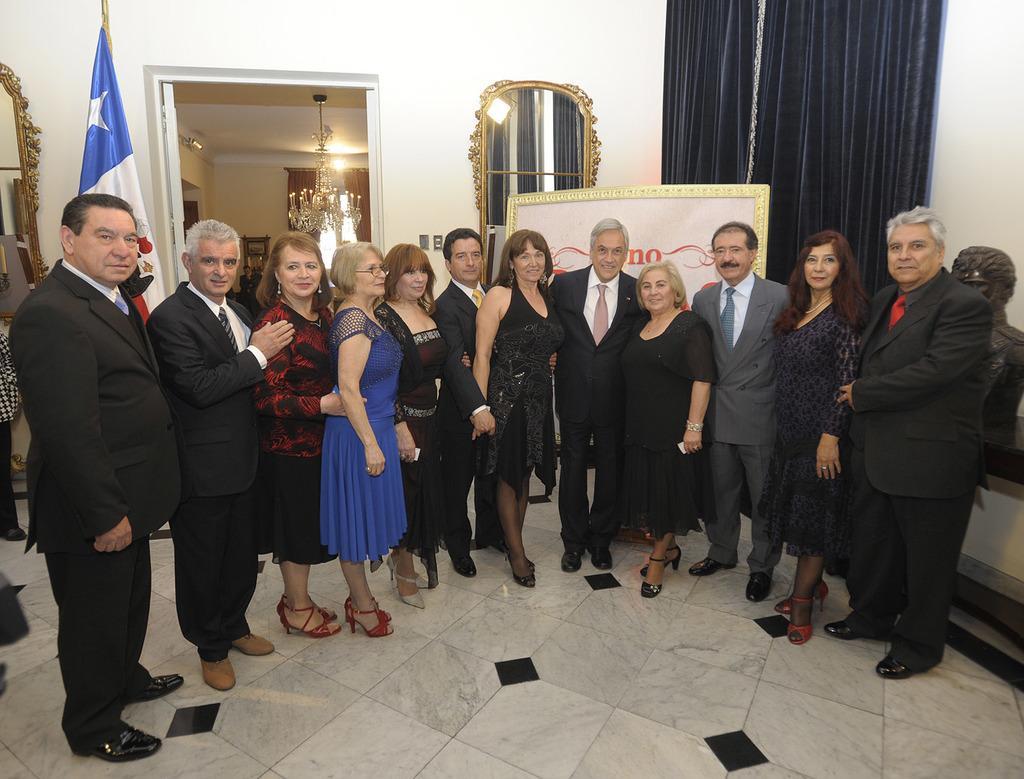Please provide a concise description of this image. In this picture we can see a group of people standing on the floor and smiling and in the background we can see a flag, mirror, curtains, framed, chandelier, wall. 